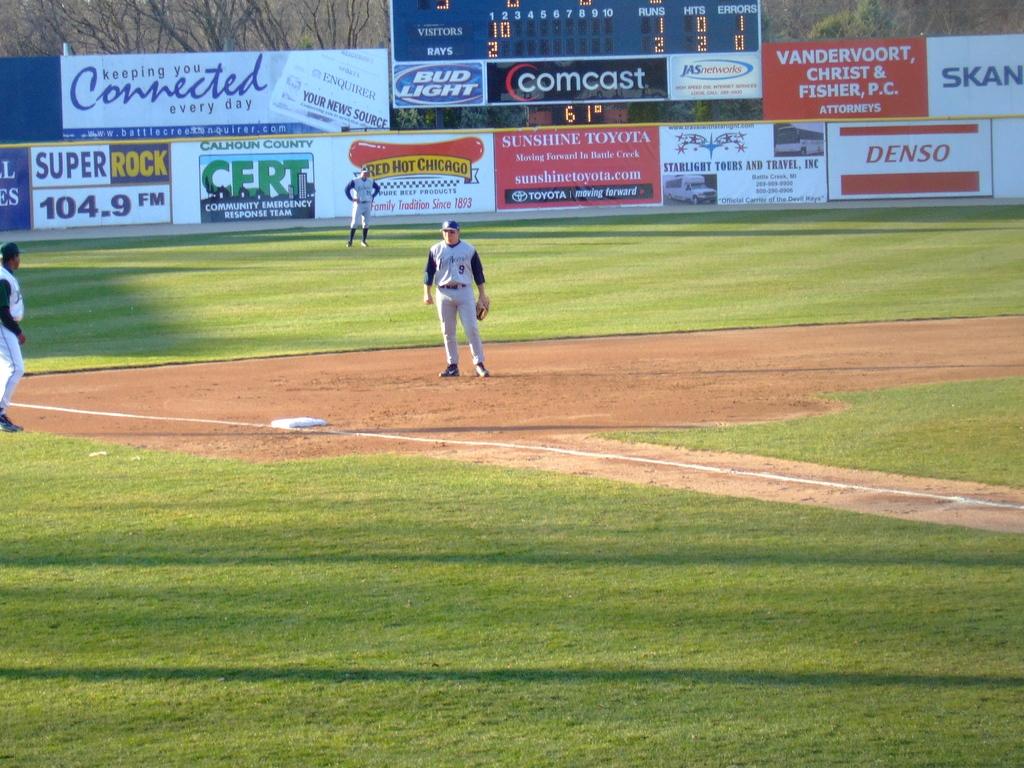What radio station is listed in the top left?
Give a very brief answer. 104.9 fm. This a playground?
Your response must be concise. No. 